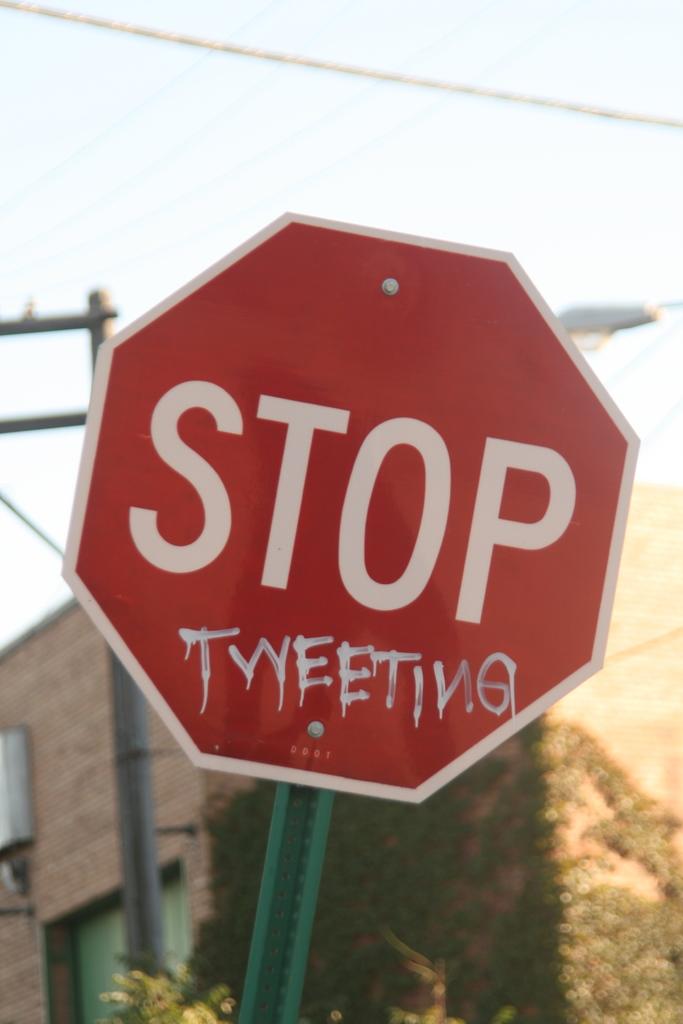What does the sign say to stop doing>?
Keep it short and to the point. Tweeting. 